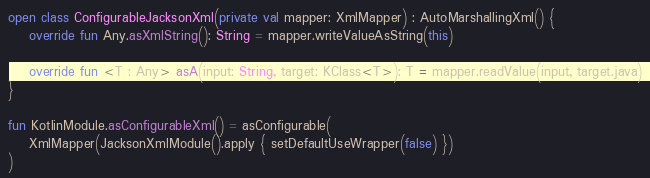<code> <loc_0><loc_0><loc_500><loc_500><_Kotlin_>open class ConfigurableJacksonXml(private val mapper: XmlMapper) : AutoMarshallingXml() {
    override fun Any.asXmlString(): String = mapper.writeValueAsString(this)

    override fun <T : Any> asA(input: String, target: KClass<T>): T = mapper.readValue(input, target.java)
}

fun KotlinModule.asConfigurableXml() = asConfigurable(
    XmlMapper(JacksonXmlModule().apply { setDefaultUseWrapper(false) })
)
</code> 